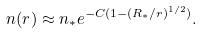Convert formula to latex. <formula><loc_0><loc_0><loc_500><loc_500>n ( r ) \approx n _ { * } e ^ { - C ( 1 - ( R _ { * } / r ) ^ { 1 / 2 } ) } .</formula> 